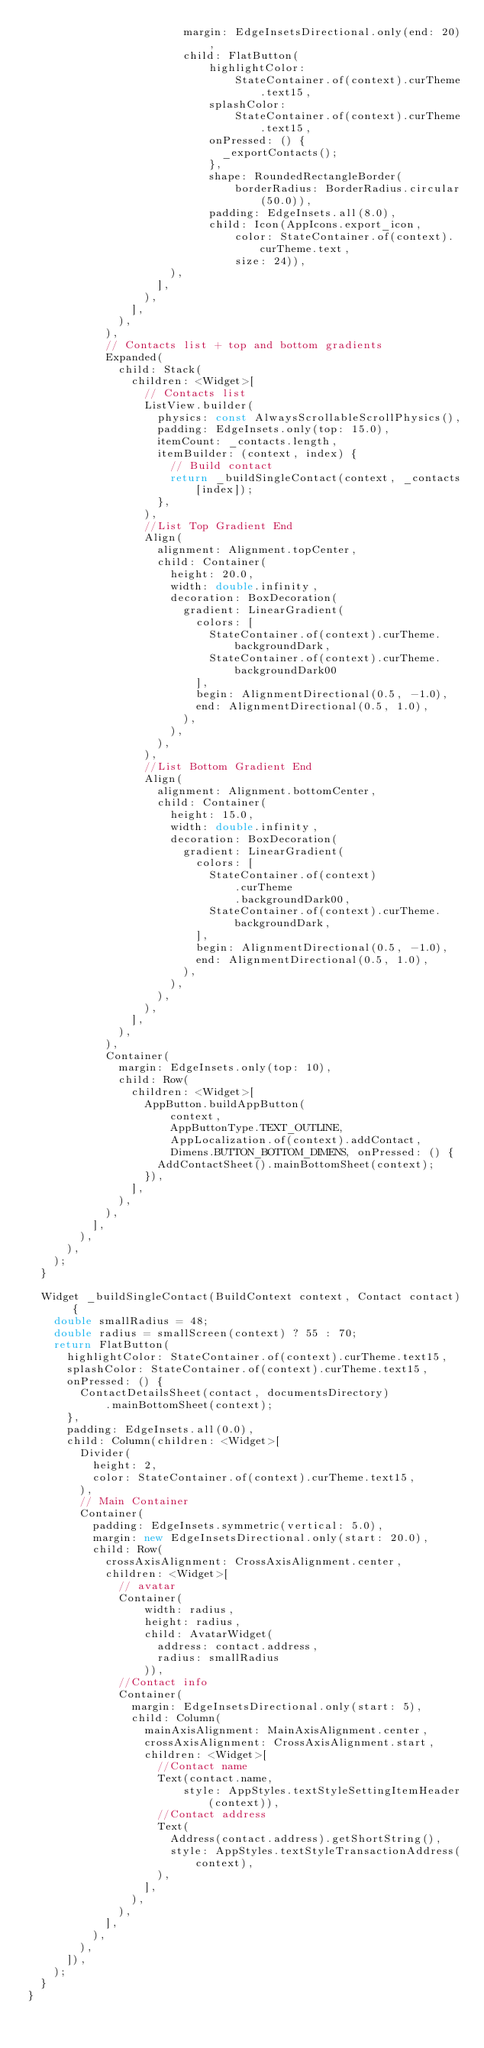<code> <loc_0><loc_0><loc_500><loc_500><_Dart_>                        margin: EdgeInsetsDirectional.only(end: 20),
                        child: FlatButton(
                            highlightColor:
                                StateContainer.of(context).curTheme.text15,
                            splashColor:
                                StateContainer.of(context).curTheme.text15,
                            onPressed: () {
                              _exportContacts();
                            },
                            shape: RoundedRectangleBorder(
                                borderRadius: BorderRadius.circular(50.0)),
                            padding: EdgeInsets.all(8.0),
                            child: Icon(AppIcons.export_icon,
                                color: StateContainer.of(context).curTheme.text,
                                size: 24)),
                      ),
                    ],
                  ),
                ],
              ),
            ),
            // Contacts list + top and bottom gradients
            Expanded(
              child: Stack(
                children: <Widget>[
                  // Contacts list
                  ListView.builder(
                    physics: const AlwaysScrollableScrollPhysics(),
                    padding: EdgeInsets.only(top: 15.0),
                    itemCount: _contacts.length,
                    itemBuilder: (context, index) {
                      // Build contact
                      return _buildSingleContact(context, _contacts[index]);
                    },
                  ),
                  //List Top Gradient End
                  Align(
                    alignment: Alignment.topCenter,
                    child: Container(
                      height: 20.0,
                      width: double.infinity,
                      decoration: BoxDecoration(
                        gradient: LinearGradient(
                          colors: [
                            StateContainer.of(context).curTheme.backgroundDark,
                            StateContainer.of(context).curTheme.backgroundDark00
                          ],
                          begin: AlignmentDirectional(0.5, -1.0),
                          end: AlignmentDirectional(0.5, 1.0),
                        ),
                      ),
                    ),
                  ),
                  //List Bottom Gradient End
                  Align(
                    alignment: Alignment.bottomCenter,
                    child: Container(
                      height: 15.0,
                      width: double.infinity,
                      decoration: BoxDecoration(
                        gradient: LinearGradient(
                          colors: [
                            StateContainer.of(context)
                                .curTheme
                                .backgroundDark00,
                            StateContainer.of(context).curTheme.backgroundDark,
                          ],
                          begin: AlignmentDirectional(0.5, -1.0),
                          end: AlignmentDirectional(0.5, 1.0),
                        ),
                      ),
                    ),
                  ),
                ],
              ),
            ),
            Container(
              margin: EdgeInsets.only(top: 10),
              child: Row(
                children: <Widget>[
                  AppButton.buildAppButton(
                      context,
                      AppButtonType.TEXT_OUTLINE,
                      AppLocalization.of(context).addContact,
                      Dimens.BUTTON_BOTTOM_DIMENS, onPressed: () {
                    AddContactSheet().mainBottomSheet(context);
                  }),
                ],
              ),
            ),
          ],
        ),
      ),
    );
  }

  Widget _buildSingleContact(BuildContext context, Contact contact) {
    double smallRadius = 48;
    double radius = smallScreen(context) ? 55 : 70;
    return FlatButton(
      highlightColor: StateContainer.of(context).curTheme.text15,
      splashColor: StateContainer.of(context).curTheme.text15,
      onPressed: () {
        ContactDetailsSheet(contact, documentsDirectory)
            .mainBottomSheet(context);
      },
      padding: EdgeInsets.all(0.0),
      child: Column(children: <Widget>[
        Divider(
          height: 2,
          color: StateContainer.of(context).curTheme.text15,
        ),
        // Main Container
        Container(
          padding: EdgeInsets.symmetric(vertical: 5.0),
          margin: new EdgeInsetsDirectional.only(start: 20.0),
          child: Row(
            crossAxisAlignment: CrossAxisAlignment.center,
            children: <Widget>[
              // avatar
              Container(
                  width: radius,
                  height: radius,
                  child: AvatarWidget(
                    address: contact.address,
                    radius: smallRadius
                  )),
              //Contact info
              Container(
                margin: EdgeInsetsDirectional.only(start: 5),
                child: Column(
                  mainAxisAlignment: MainAxisAlignment.center,
                  crossAxisAlignment: CrossAxisAlignment.start,
                  children: <Widget>[
                    //Contact name
                    Text(contact.name,
                        style: AppStyles.textStyleSettingItemHeader(context)),
                    //Contact address
                    Text(
                      Address(contact.address).getShortString(),
                      style: AppStyles.textStyleTransactionAddress(context),
                    ),
                  ],
                ),
              ),
            ],
          ),
        ),
      ]),
    );
  }
}
</code> 